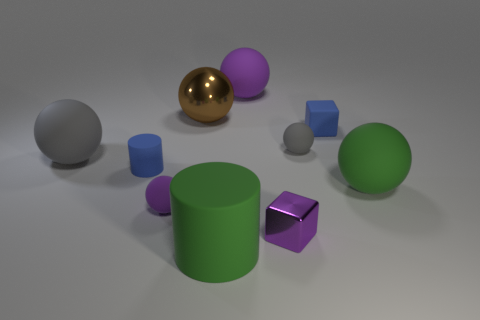How many small cylinders are the same color as the rubber block?
Your response must be concise. 1. What number of objects are tiny blue objects right of the small cylinder or gray rubber spheres?
Keep it short and to the point. 3. There is a cylinder to the left of the big brown metal object; what is its size?
Offer a terse response. Small. Are there fewer tiny brown balls than tiny cylinders?
Your response must be concise. Yes. Is the material of the cylinder that is in front of the green rubber sphere the same as the tiny blue thing in front of the big gray ball?
Offer a very short reply. Yes. What is the shape of the blue matte object that is behind the tiny blue object that is to the left of the tiny cube behind the big gray sphere?
Make the answer very short. Cube. How many gray things are the same material as the large green sphere?
Provide a succinct answer. 2. How many large brown metallic objects are to the right of the blue rubber thing that is left of the tiny metal block?
Your answer should be very brief. 1. There is a big matte object that is in front of the tiny purple matte object; is its color the same as the large matte ball on the right side of the small gray rubber thing?
Offer a terse response. Yes. There is a big thing that is in front of the big gray thing and left of the blue cube; what shape is it?
Ensure brevity in your answer.  Cylinder. 